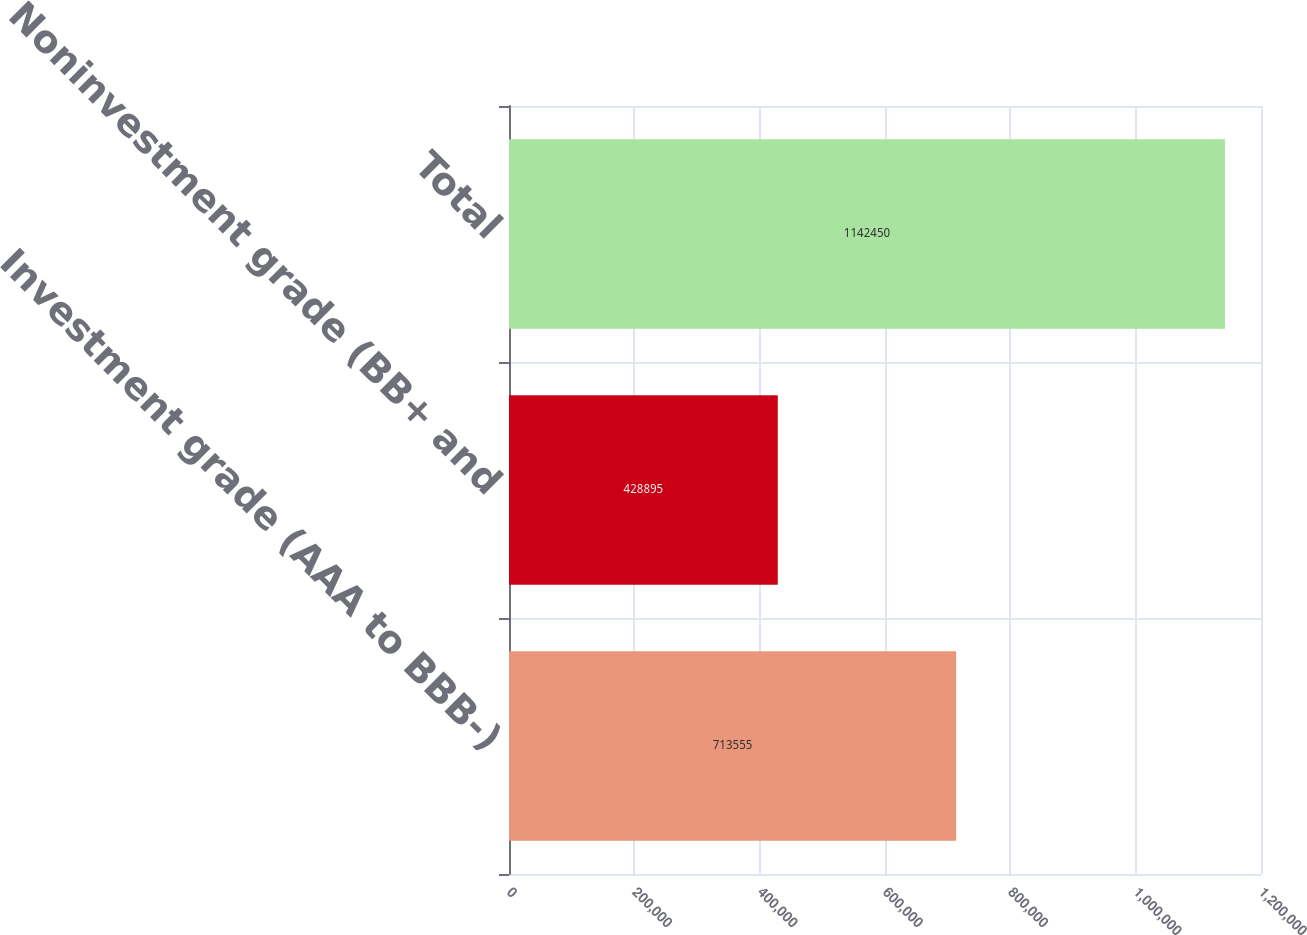Convert chart. <chart><loc_0><loc_0><loc_500><loc_500><bar_chart><fcel>Investment grade (AAA to BBB-)<fcel>Noninvestment grade (BB+ and<fcel>Total<nl><fcel>713555<fcel>428895<fcel>1.14245e+06<nl></chart> 